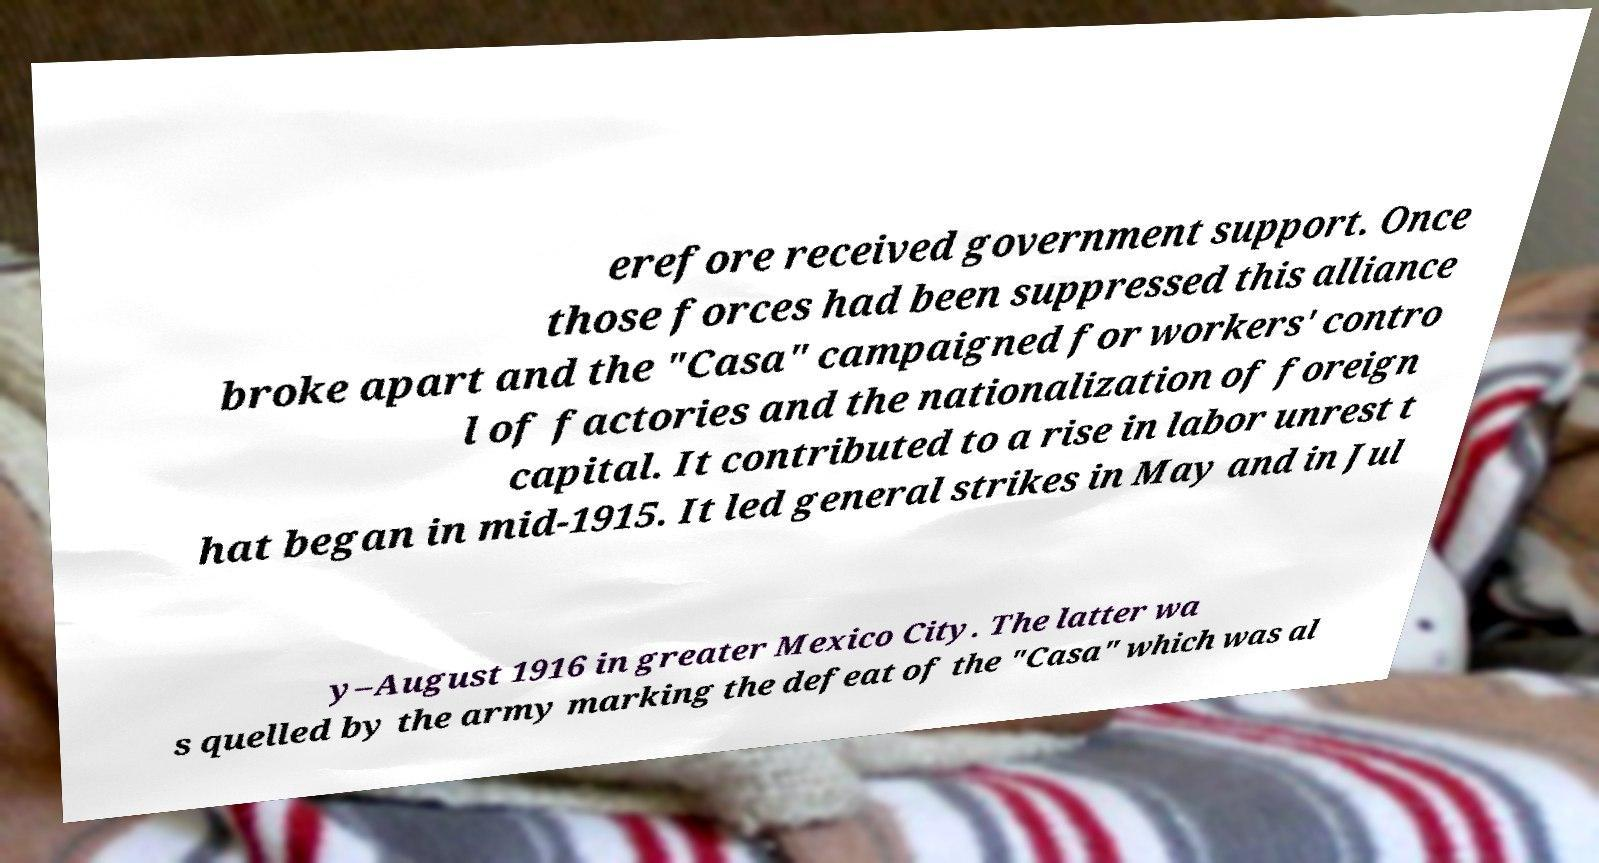Could you extract and type out the text from this image? erefore received government support. Once those forces had been suppressed this alliance broke apart and the "Casa" campaigned for workers' contro l of factories and the nationalization of foreign capital. It contributed to a rise in labor unrest t hat began in mid-1915. It led general strikes in May and in Jul y–August 1916 in greater Mexico City. The latter wa s quelled by the army marking the defeat of the "Casa" which was al 